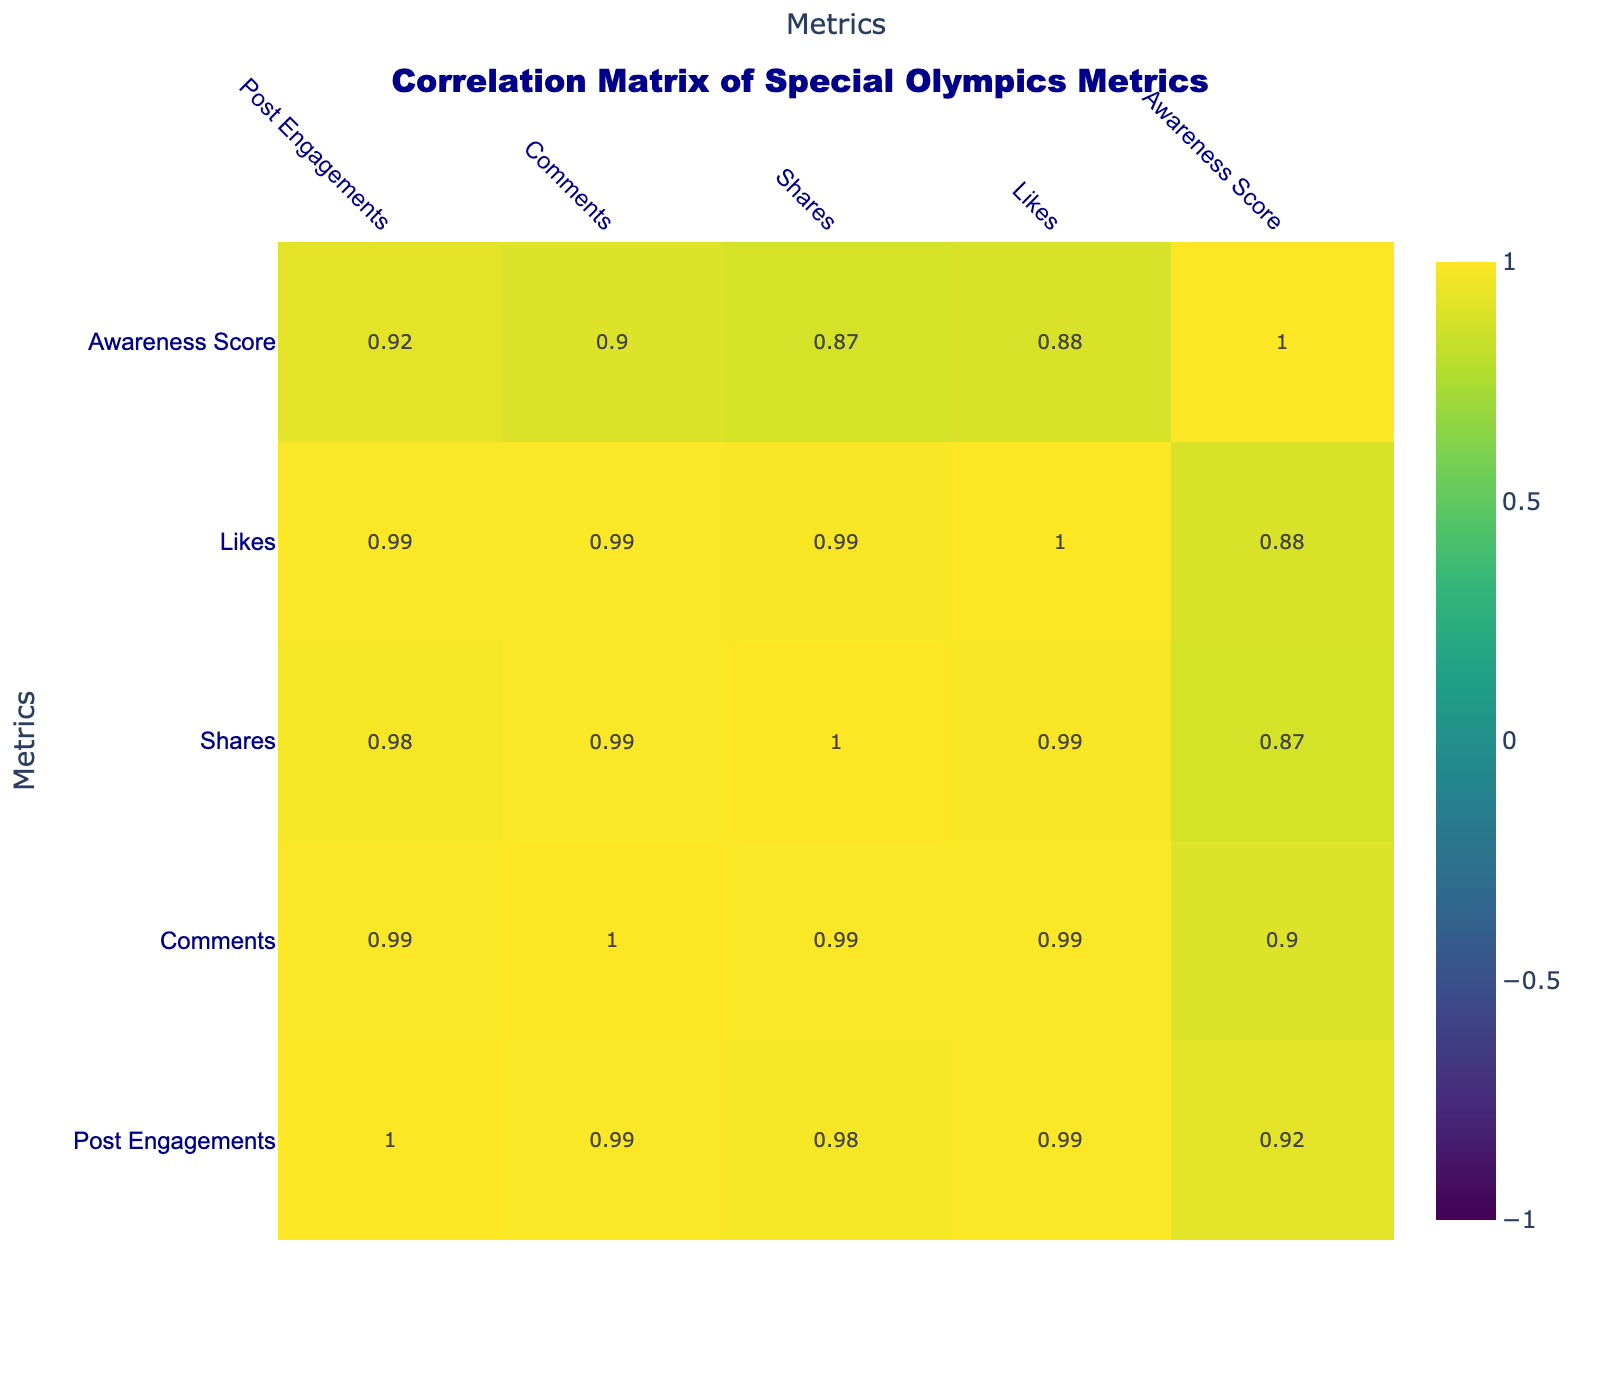What is the Awareness Score for the Unified Soccer Tournament? The Awareness Score is explicitly listed for each event, and for the Unified Soccer Tournament, it is directly provided in the table as 90.
Answer: 90 How many Likes did the Special Olympics World Games receive? The number of Likes for each event is directly indicated in the table, and the Special Olympics World Games received 3000 Likes.
Answer: 3000 What is the total number of Post Engagements for the #ChooseToInclude Campaign and the Unified Champion Schools Program combined? To find the total Post Engagements, add the values for both campaigns: #ChooseToInclude Campaign has 3500 engagements and Unified Champion Schools Program has 1800 engagements, so the total is 3500 + 1800 = 5300.
Answer: 5300 Is the Awareness Score for the Virtual Fundraising Gala above 80? The Awareness Score for the Virtual Fundraising Gala is given in the table as 75, which is below 80. Therefore, the answer is no.
Answer: No Which event had the lowest Awareness Score, and what was that score? To determine the event with the lowest Awareness Score, we can compare the values provided in the Awareness Score column. The lowest score is 60 for the Encouragement through Arts Program.
Answer: Encouragement through Arts Program, 60 What is the difference in Shares between the Virtual Snowshoeing Challenge and the Fitness Challenge for Inclusion? To calculate the difference in Shares, we take the Shares for the Virtual Snowshoeing Challenge, which is 300, and the Shares for the Fitness Challenge for Inclusion, which is 70. The difference is 300 - 70 = 230.
Answer: 230 What is the average Awareness Score of all events listed in the table? To find the average Awareness Score, we first sum all the scores: 80 + 90 + 70 + 95 + 100 + 75 + 85 + 65 + 92 + 60 =  912. There are 10 events, so dividing the total (912) by the number of events (10) gives us an average of 91.2.
Answer: 91.2 Did the Global Day of Inclusion have more Comments than the Virtual Fundraising Gala? The table lists 250 Comments for the Global Day of Inclusion and 50 for the Virtual Fundraising Gala. Since 250 is greater than 50, the answer is yes.
Answer: Yes Which event had the highest number of Shares, and how many were there? By examining the Shares for each event, we find that the Special Olympics World Games had the highest number at 1200 Shares.
Answer: Special Olympics World Games, 1200 